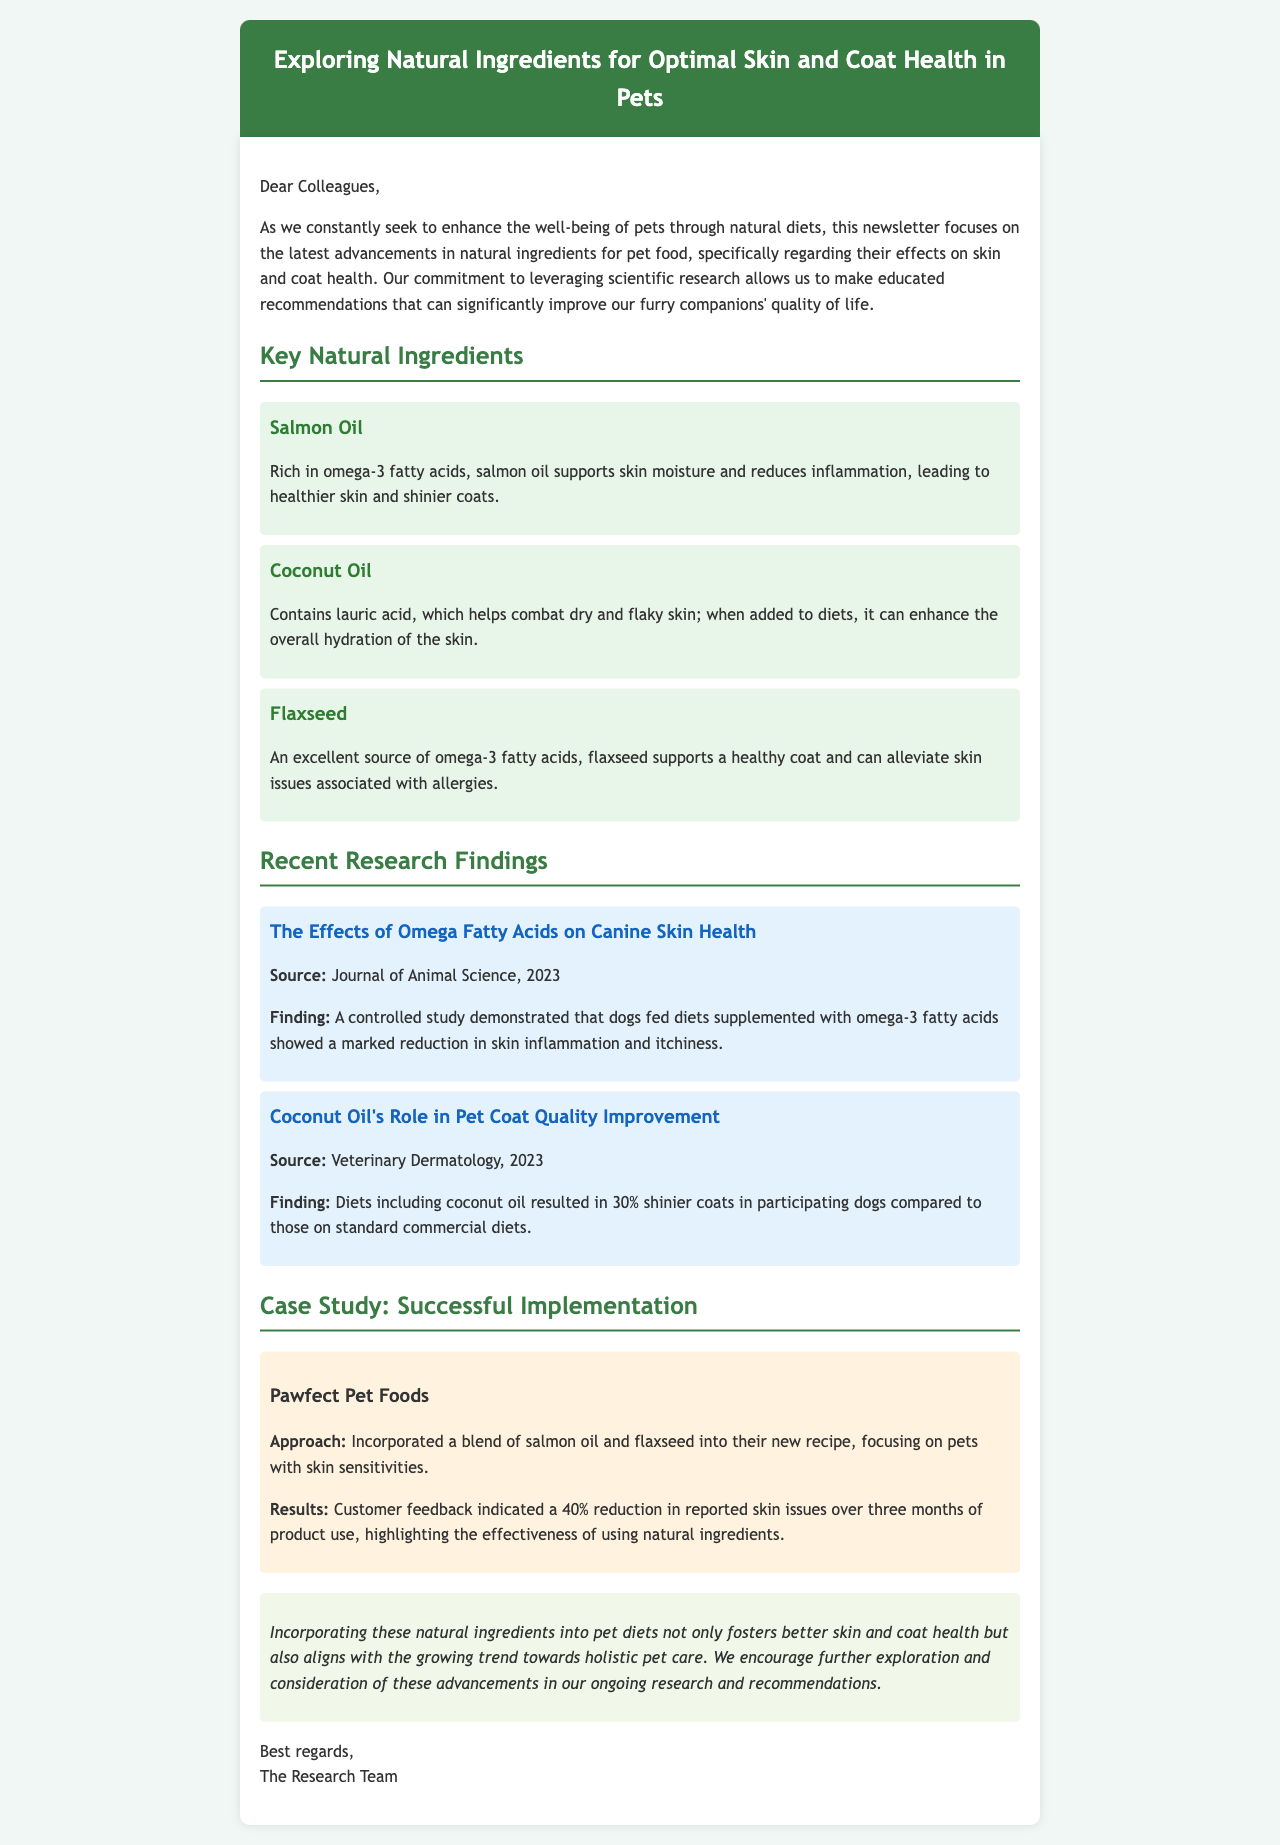What is the main focus of the newsletter? The main focus of the newsletter is the latest advancements in natural ingredients for pet food, specifically regarding their effects on skin and coat health.
Answer: natural ingredients for pet food How many key natural ingredients are listed? There are three key natural ingredients listed in the newsletter.
Answer: three What is the source of the study on omega fatty acids? The source of the study is the Journal of Animal Science, published in 2023.
Answer: Journal of Animal Science What percentage increase in coat shininess was reported with coconut oil diets? The study reported a 30% increase in coat shininess with coconut oil diets.
Answer: 30% What specific ingredient was incorporated by Pawfect Pet Foods? Pawfect Pet Foods incorporated a blend of salmon oil and flaxseed into their new recipe.
Answer: salmon oil and flaxseed What percentage reduction in skin issues was reported by customers after using the new product? Customers reported a 40% reduction in reported skin issues over three months of product use.
Answer: 40% Which ingredient supports skin moisture according to the document? Salmon oil is stated to support skin moisture.
Answer: Salmon oil What year did the study on coconut oil's role in pet coat quality improvement take place? The study on coconut oil's role occurred in 2023.
Answer: 2023 What is the purpose of the newsletter according to the closing statement? The purpose of the newsletter includes encouraging further exploration and consideration of advancements in pet diets.
Answer: encourage further exploration 